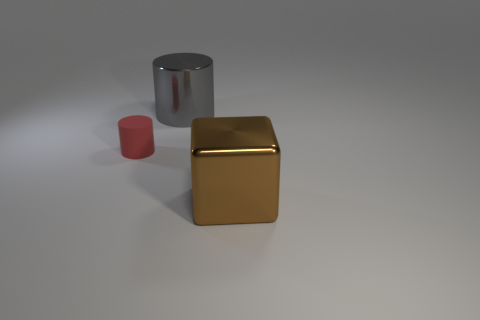Add 3 tiny cylinders. How many objects exist? 6 Subtract all cubes. How many objects are left? 2 Add 2 large spheres. How many large spheres exist? 2 Subtract 1 gray cylinders. How many objects are left? 2 Subtract all small gray balls. Subtract all tiny red matte cylinders. How many objects are left? 2 Add 1 gray cylinders. How many gray cylinders are left? 2 